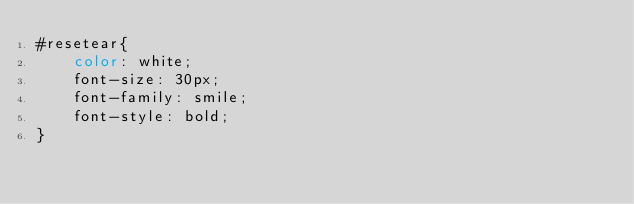<code> <loc_0><loc_0><loc_500><loc_500><_CSS_>#resetear{
	color: white;
	font-size: 30px;
	font-family: smile;
	font-style: bold;
}</code> 